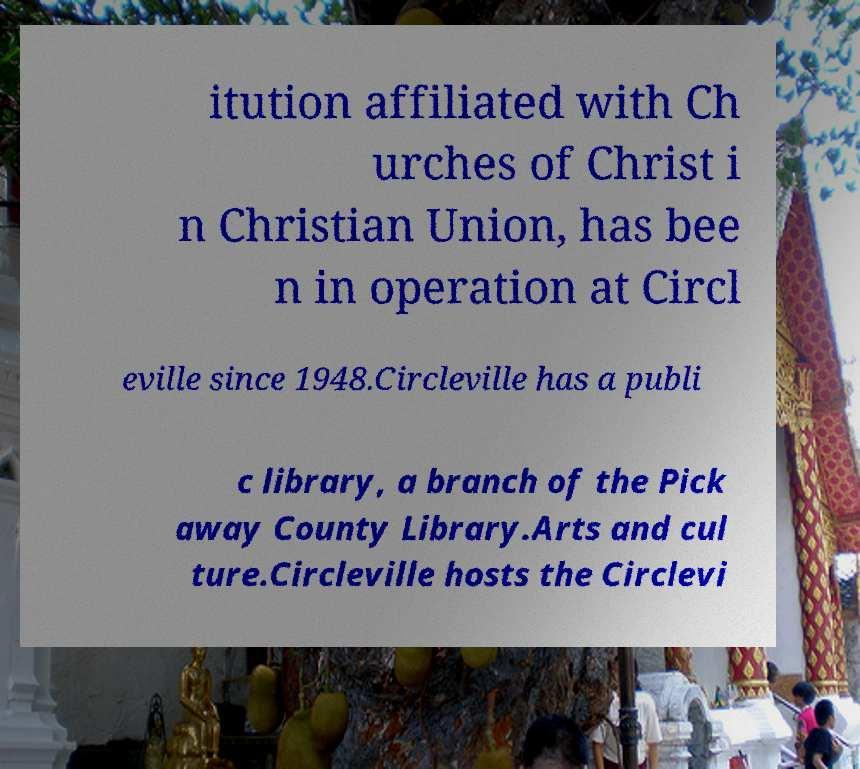I need the written content from this picture converted into text. Can you do that? itution affiliated with Ch urches of Christ i n Christian Union, has bee n in operation at Circl eville since 1948.Circleville has a publi c library, a branch of the Pick away County Library.Arts and cul ture.Circleville hosts the Circlevi 